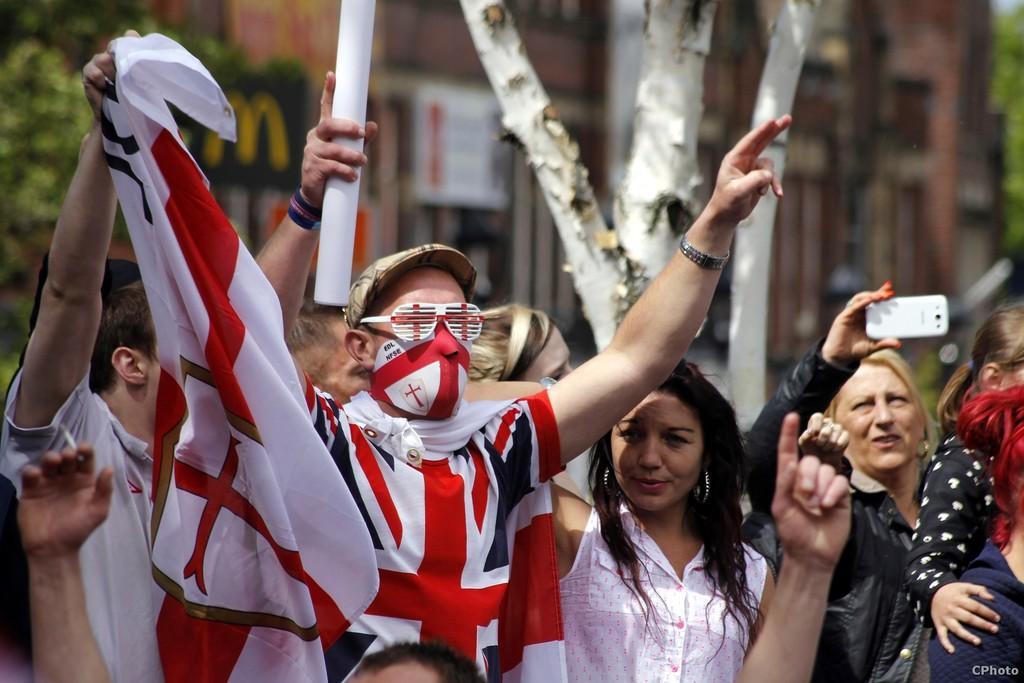Describe this image in one or two sentences. In this picture we can see some persons. She is holding a mobile with her hand. On the background we can see a building. And this is tree. 